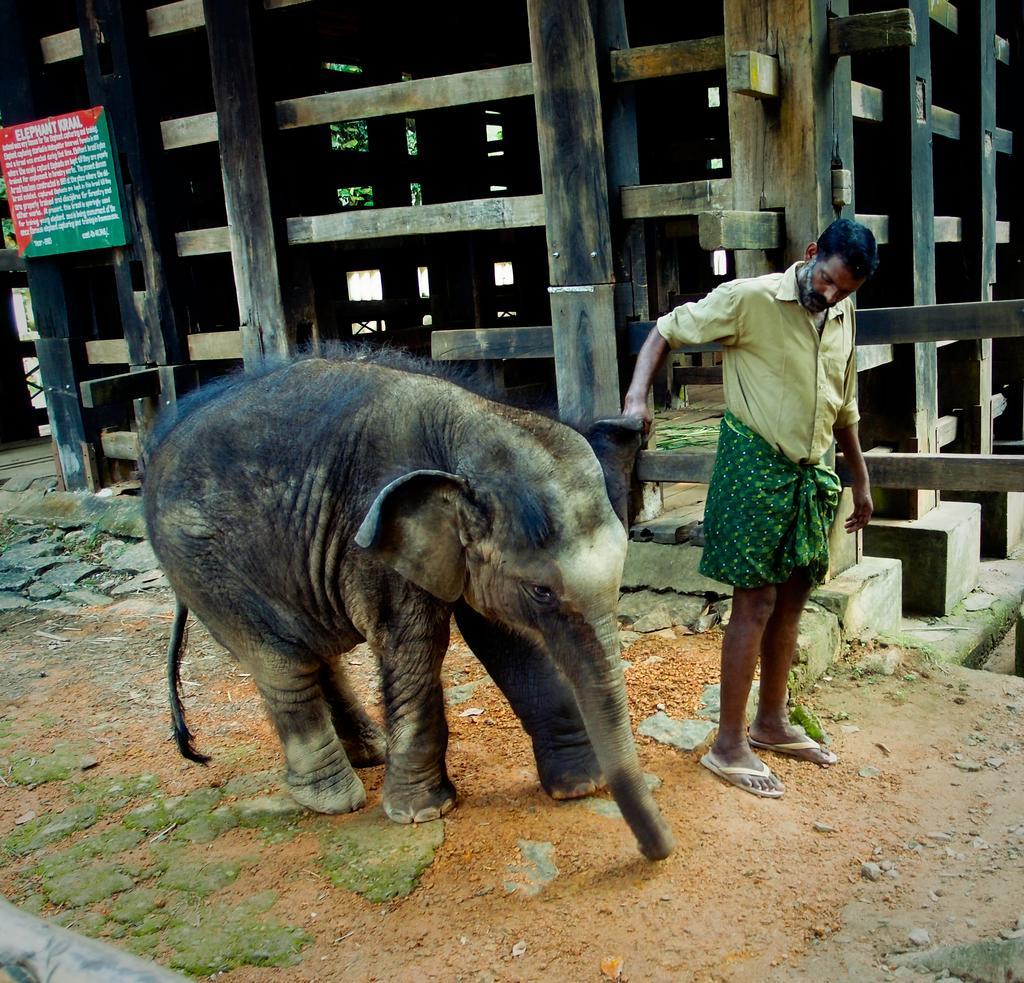Please provide a concise description of this image. In this picture I can see a elephant and a man standing, there is a board, there is an elephant wooden cage, and there is a tree. 